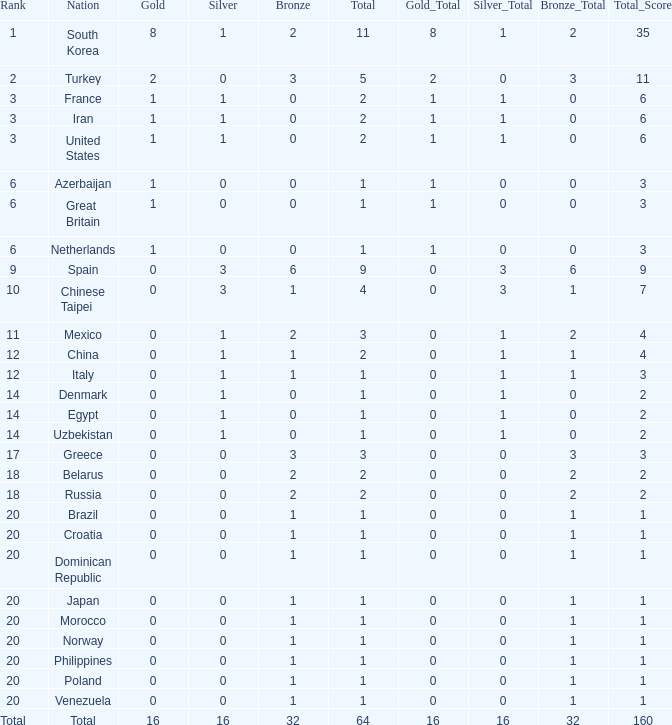What is the average number of bronze medals of the Philippines, which has more than 0 gold? None. 